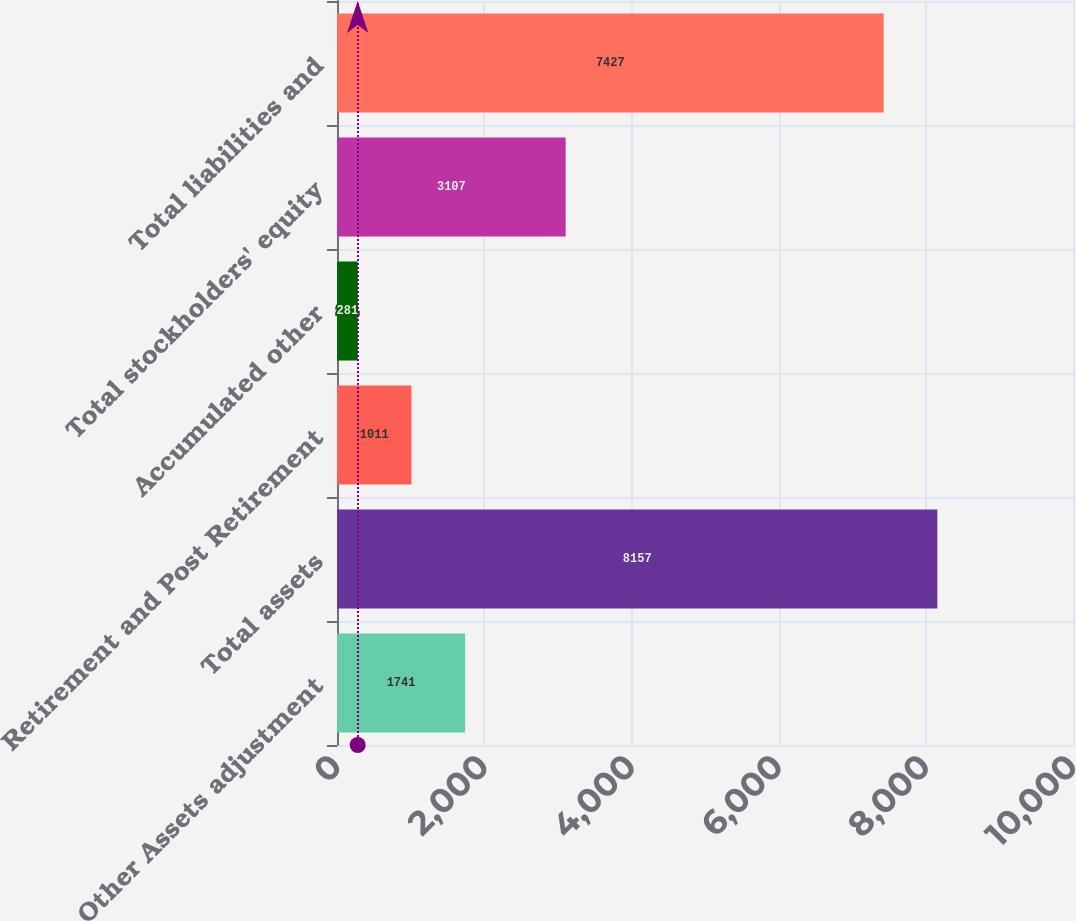Convert chart to OTSL. <chart><loc_0><loc_0><loc_500><loc_500><bar_chart><fcel>Other Assets adjustment<fcel>Total assets<fcel>Retirement and Post Retirement<fcel>Accumulated other<fcel>Total stockholders' equity<fcel>Total liabilities and<nl><fcel>1741<fcel>8157<fcel>1011<fcel>281<fcel>3107<fcel>7427<nl></chart> 